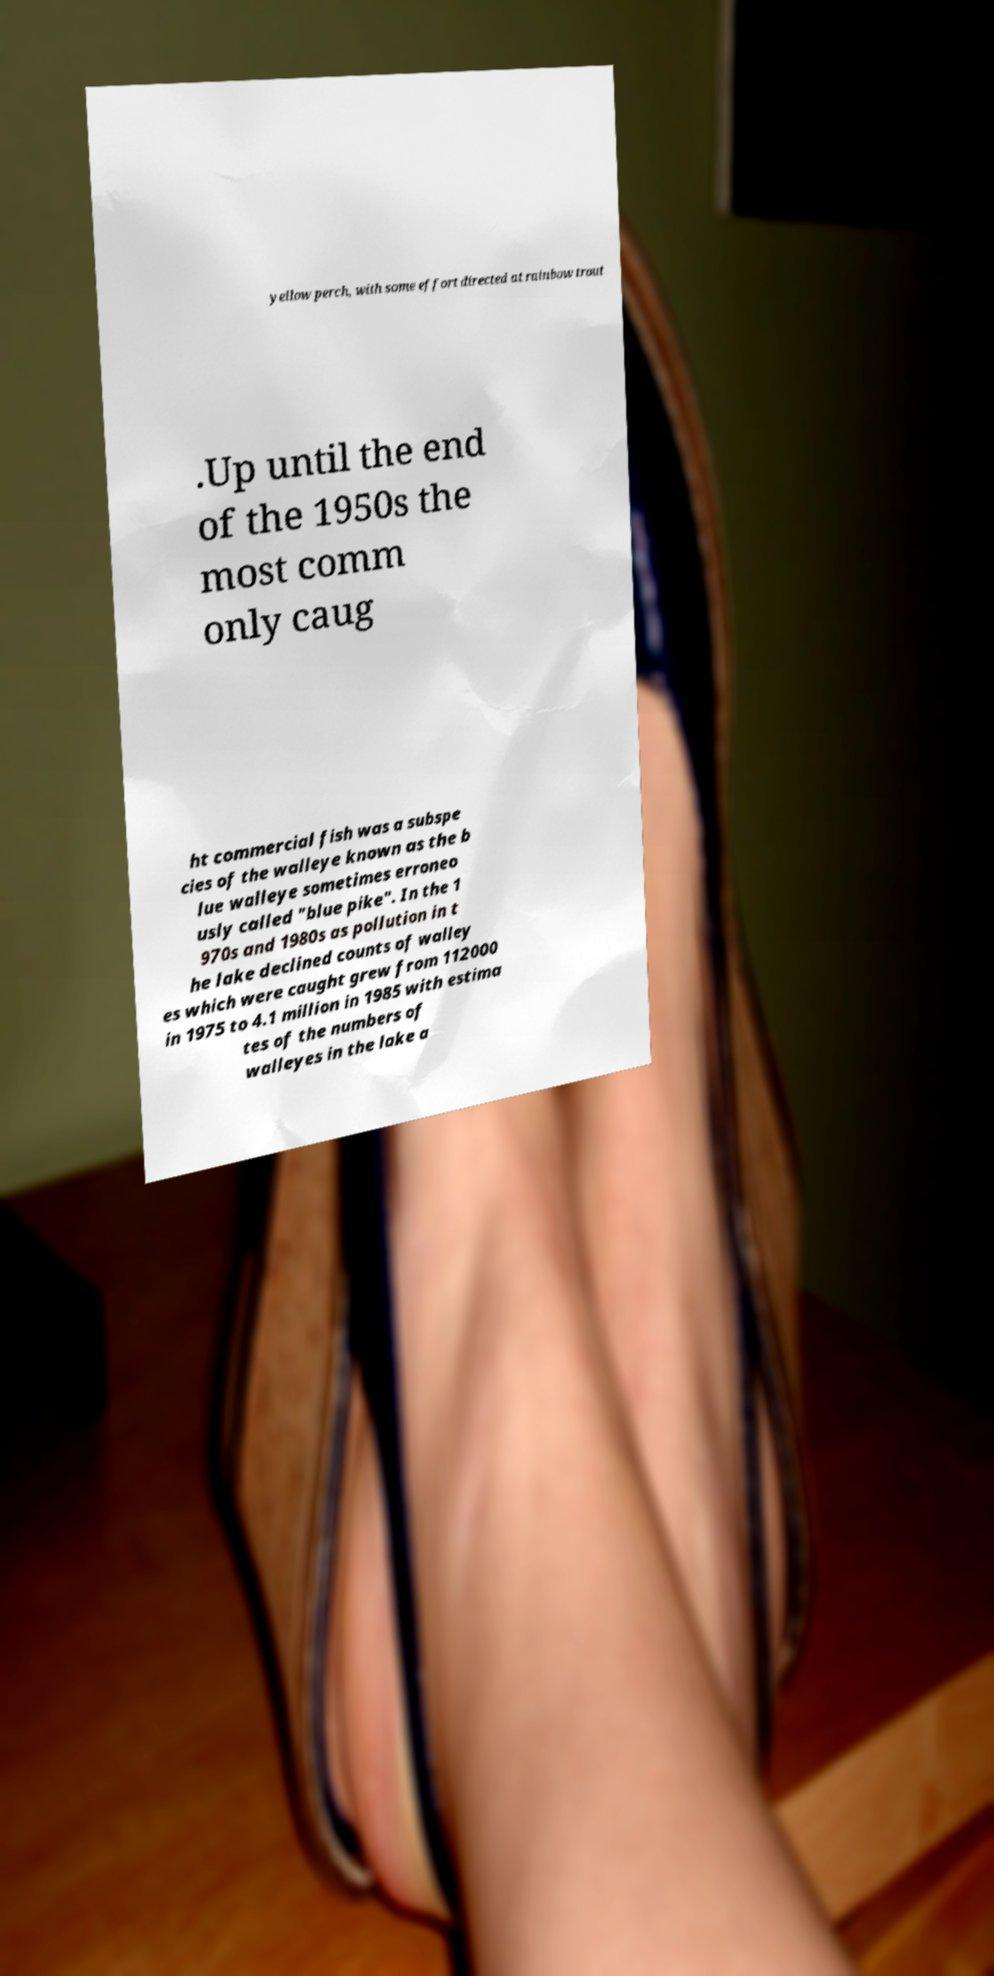Can you accurately transcribe the text from the provided image for me? yellow perch, with some effort directed at rainbow trout .Up until the end of the 1950s the most comm only caug ht commercial fish was a subspe cies of the walleye known as the b lue walleye sometimes erroneo usly called "blue pike". In the 1 970s and 1980s as pollution in t he lake declined counts of walley es which were caught grew from 112000 in 1975 to 4.1 million in 1985 with estima tes of the numbers of walleyes in the lake a 